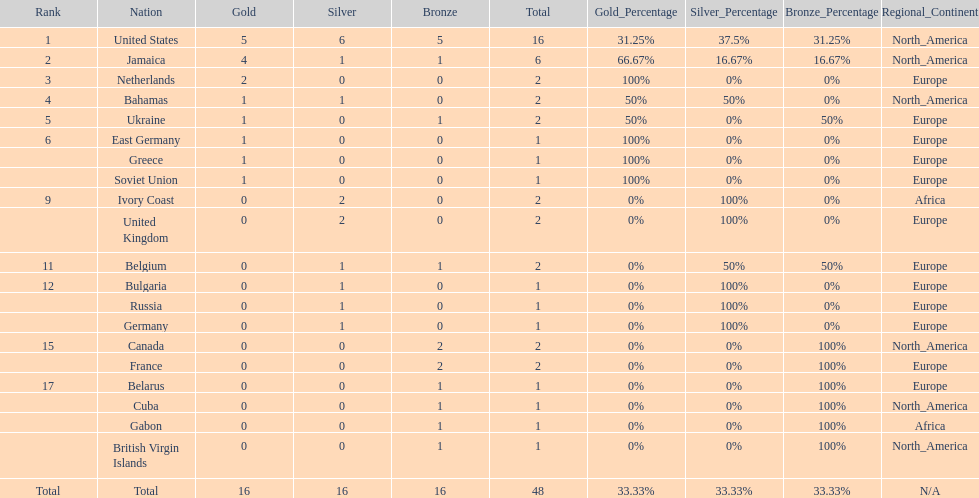What is the total number of gold medals won by jamaica? 4. 